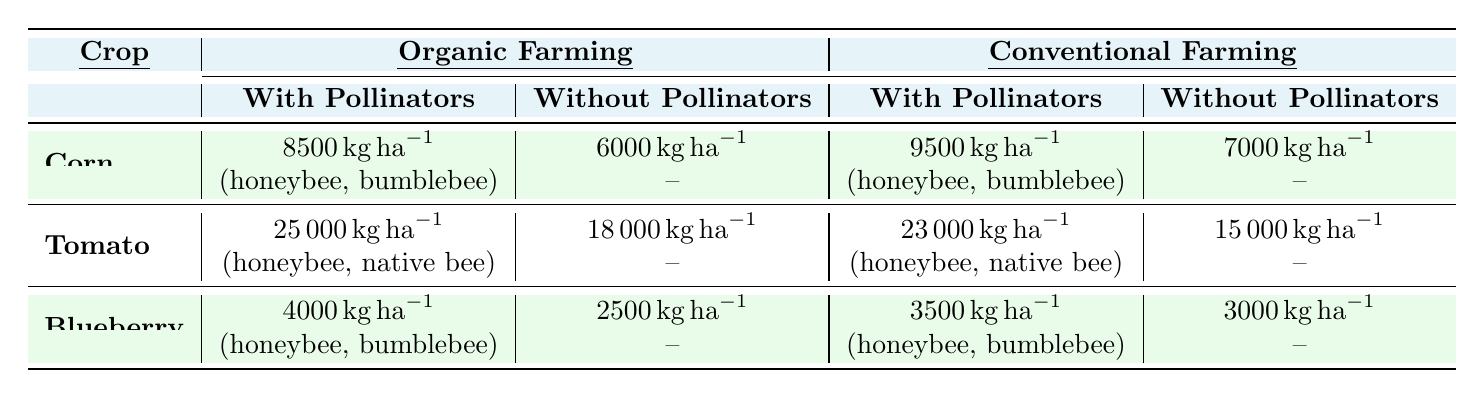What is the average yield of corn with pollinators in organic farming? According to the table, the average yield of corn with pollinators in organic farming is 8500 kg per hectare as shown in the first row under the "With Pollinators" column for organic farming.
Answer: 8500 kg per hectare What is the yield difference for tomatoes with and without pollinators in conventional farming? For tomatoes in conventional farming, the yield with pollinators is 23000 kg per hectare, and without pollinators, it is 15000 kg per hectare. The difference is 23000 - 15000 = 8000 kg per hectare.
Answer: 8000 kg per hectare Do blueberries in organic farming yield more with pollinators compared to without? In organic farming, blueberries yield 4000 kg per hectare with pollinators and 2500 kg per hectare without. Since 4000 kg is greater than 2500 kg, the statement is true.
Answer: Yes What is the total yield of corn in both farming systems when pollinators are present? The yield of corn in organic farming with pollinators is 8500 kg per hectare and in conventional farming with pollinators is 9500 kg per hectare. The total yield is 8500 + 9500 = 18000 kg per hectare across both systems.
Answer: 18000 kg per hectare Which crop benefits the most from pollinator presence in organic farming based on yield? The yields with pollinators in organic farming are: corn at 8500 kg, tomatoes at 25000 kg, and blueberries at 4000 kg. Tomatoes with 25000 kg have the highest yield attributed to pollinators, thus benefiting the most.
Answer: Tomatoes What is the average yield of blueberries in conventional farming? In conventional farming, blueberries yield 3500 kg per hectare with pollinators and 3000 kg per hectare without. The average yield is (3500 + 3000) / 2 = 3250 kg per hectare.
Answer: 3250 kg per hectare Is the average yield of corn without pollinators higher in organic or conventional farming? In organic farming, the yield of corn without pollinators is 6000 kg per hectare, while in conventional farming, it is 7000 kg per hectare. Since 7000 kg is greater than 6000 kg, the statement is false.
Answer: No What is the overall yield of tomatoes in organic farming with pollinators compared to conventional farming? The yield of tomatoes with pollinators in organic farming is 25000 kg per hectare, while in conventional farming, it is 23000 kg per hectare. Organic farming has the higher yield at 25000 kg.
Answer: Organic farming How much more does corn yield with pollinators in conventional farming than without? In conventional farming, corn yields 9500 kg per hectare with pollinators and 7000 kg without. The difference is 9500 - 7000 = 2500 kg, meaning it yields 2500 kg more with pollinators.
Answer: 2500 kg What crop has the least yield in organic farming without pollinators? The yields for crops without pollinators in organic farming are: corn at 6000 kg, tomatoes at 18000 kg, and blueberries at 2500 kg. Blueberries have the least yield at 2500 kg without pollinators.
Answer: Blueberries 